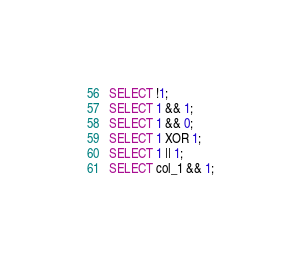Convert code to text. <code><loc_0><loc_0><loc_500><loc_500><_SQL_>SELECT !1;
SELECT 1 && 1;
SELECT 1 && 0;
SELECT 1 XOR 1;
SELECT 1 || 1;
SELECT col_1 && 1;</code> 